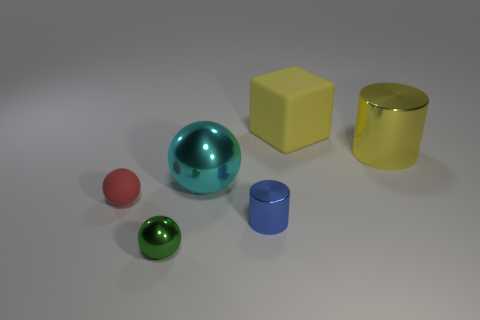Subtract all small shiny spheres. How many spheres are left? 2 Subtract 1 spheres. How many spheres are left? 2 Subtract all red spheres. How many spheres are left? 2 Add 1 yellow shiny objects. How many objects exist? 7 Subtract all cyan cylinders. Subtract all purple cubes. How many cylinders are left? 2 Subtract all red matte cylinders. Subtract all big objects. How many objects are left? 3 Add 2 yellow shiny cylinders. How many yellow shiny cylinders are left? 3 Add 3 small yellow metal cylinders. How many small yellow metal cylinders exist? 3 Subtract 0 purple cylinders. How many objects are left? 6 Subtract all cylinders. How many objects are left? 4 